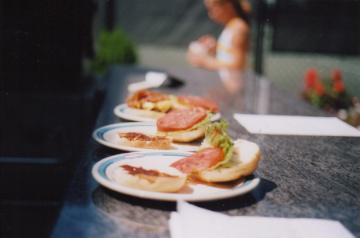What food is on this plate?
Give a very brief answer. Sandwich. Are these healthy?
Give a very brief answer. Yes. How many tomatoes is on the dish?
Give a very brief answer. 1. Are tomatoes being served?
Write a very short answer. Yes. Are these buns without burgers?
Be succinct. Yes. What color are the counters?
Give a very brief answer. Gray. 